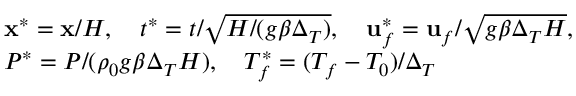Convert formula to latex. <formula><loc_0><loc_0><loc_500><loc_500>\begin{array} { r l } & { x ^ { * } = x / H , \quad t ^ { * } = t / \sqrt { H / ( g \beta \Delta _ { T } ) } , \quad u _ { f } ^ { * } = u _ { f } / \sqrt { g \beta \Delta _ { T } H } , } \\ & { P ^ { * } = P / ( \rho _ { 0 } g \beta \Delta _ { T } H ) , \quad T _ { f } ^ { * } = ( T _ { f } - T _ { 0 } ) / \Delta _ { T } } \end{array}</formula> 